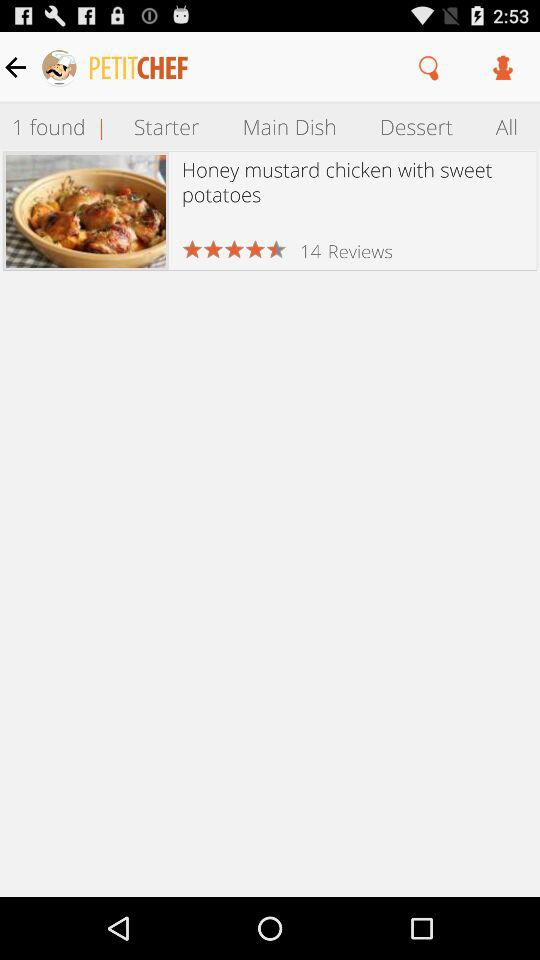How many stars did customers give the dish out of 5? Customers gave the dish 4.5 out of 5 stars. 